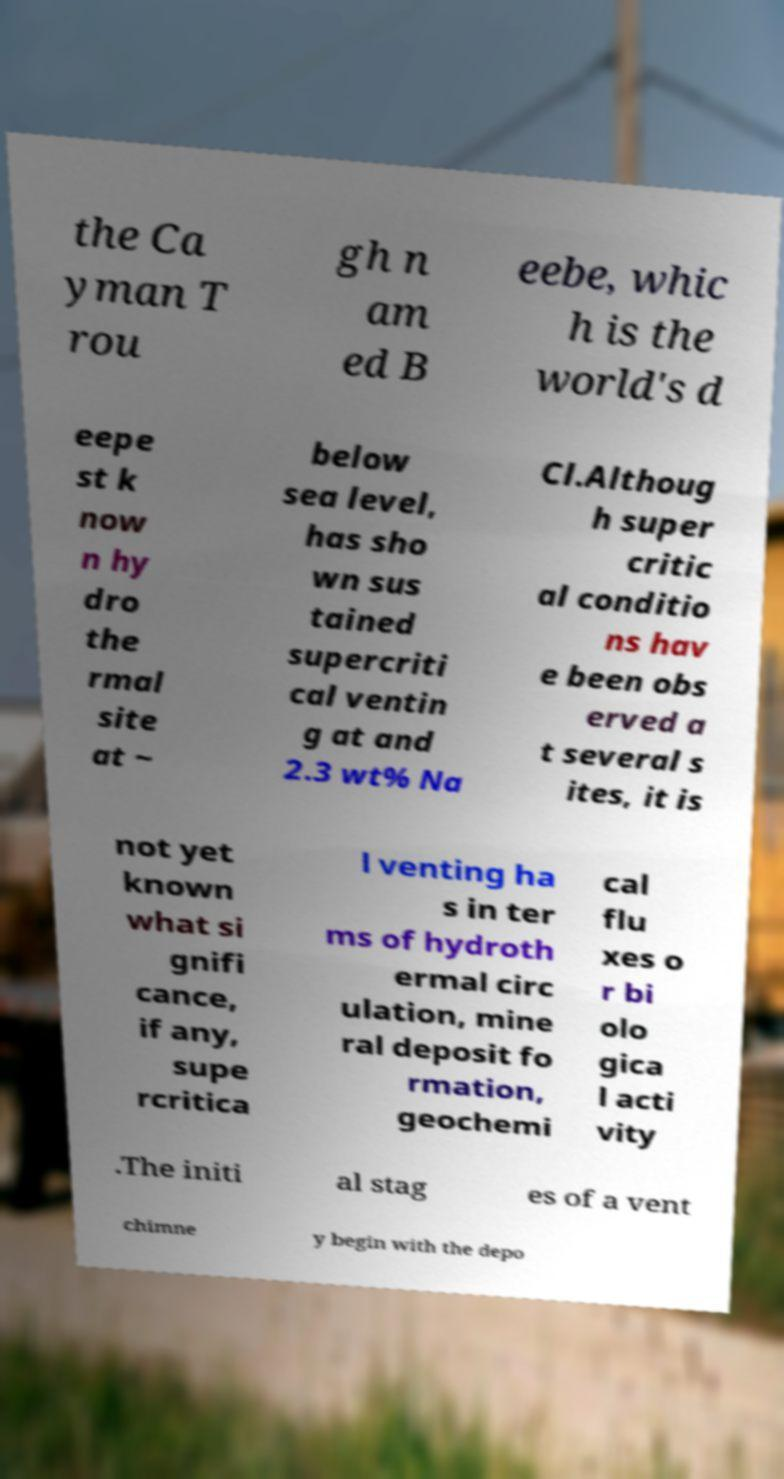Please identify and transcribe the text found in this image. the Ca yman T rou gh n am ed B eebe, whic h is the world's d eepe st k now n hy dro the rmal site at ~ below sea level, has sho wn sus tained supercriti cal ventin g at and 2.3 wt% Na Cl.Althoug h super critic al conditio ns hav e been obs erved a t several s ites, it is not yet known what si gnifi cance, if any, supe rcritica l venting ha s in ter ms of hydroth ermal circ ulation, mine ral deposit fo rmation, geochemi cal flu xes o r bi olo gica l acti vity .The initi al stag es of a vent chimne y begin with the depo 